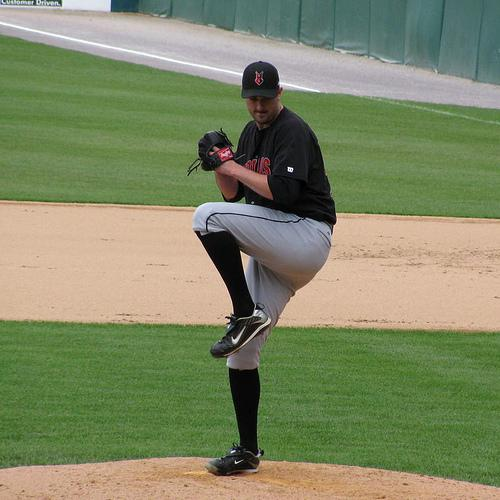Question: why the white line?
Choices:
A. Out of black paint.
B. Easy to see.
C. Out of bounds.
D. Traffic control.
Answer with the letter. Answer: C Question: what is he doing?
Choices:
A. Eating.
B. Pitching.
C. Running.
D. Reading.
Answer with the letter. Answer: B Question: who is it?
Choices:
A. Catcher.
B. Umpire.
C. Hitter.
D. Pitcher.
Answer with the letter. Answer: D Question: how many people?
Choices:
A. 1.
B. 2.
C. 3.
D. 4.
Answer with the letter. Answer: A Question: what is color pants?
Choices:
A. Red.
B. Orange.
C. Maroon.
D. Gray.
Answer with the letter. Answer: D Question: where is it?
Choices:
A. Baseball stadium.
B. Outside.
C. By the store.
D. In your room.
Answer with the letter. Answer: A 